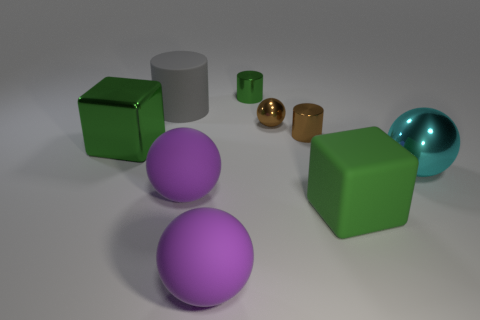There is a green cube that is behind the block in front of the large green metal cube; how many big shiny blocks are in front of it?
Offer a very short reply. 0. Do the big block on the right side of the metal block and the tiny metallic sphere have the same color?
Ensure brevity in your answer.  No. What number of other things are the same shape as the cyan metal thing?
Give a very brief answer. 3. What number of other objects are there of the same material as the cyan object?
Keep it short and to the point. 4. There is a large cube behind the green block that is right of the big object that is behind the big shiny cube; what is it made of?
Offer a very short reply. Metal. Does the tiny sphere have the same material as the tiny brown cylinder?
Ensure brevity in your answer.  Yes. What number of cubes are brown things or purple rubber objects?
Your answer should be compact. 0. What color is the big matte sphere behind the big green rubber block?
Provide a short and direct response. Purple. How many rubber things are cubes or tiny objects?
Your response must be concise. 1. What material is the large block to the right of the green metal object that is in front of the small brown shiny cylinder?
Make the answer very short. Rubber. 